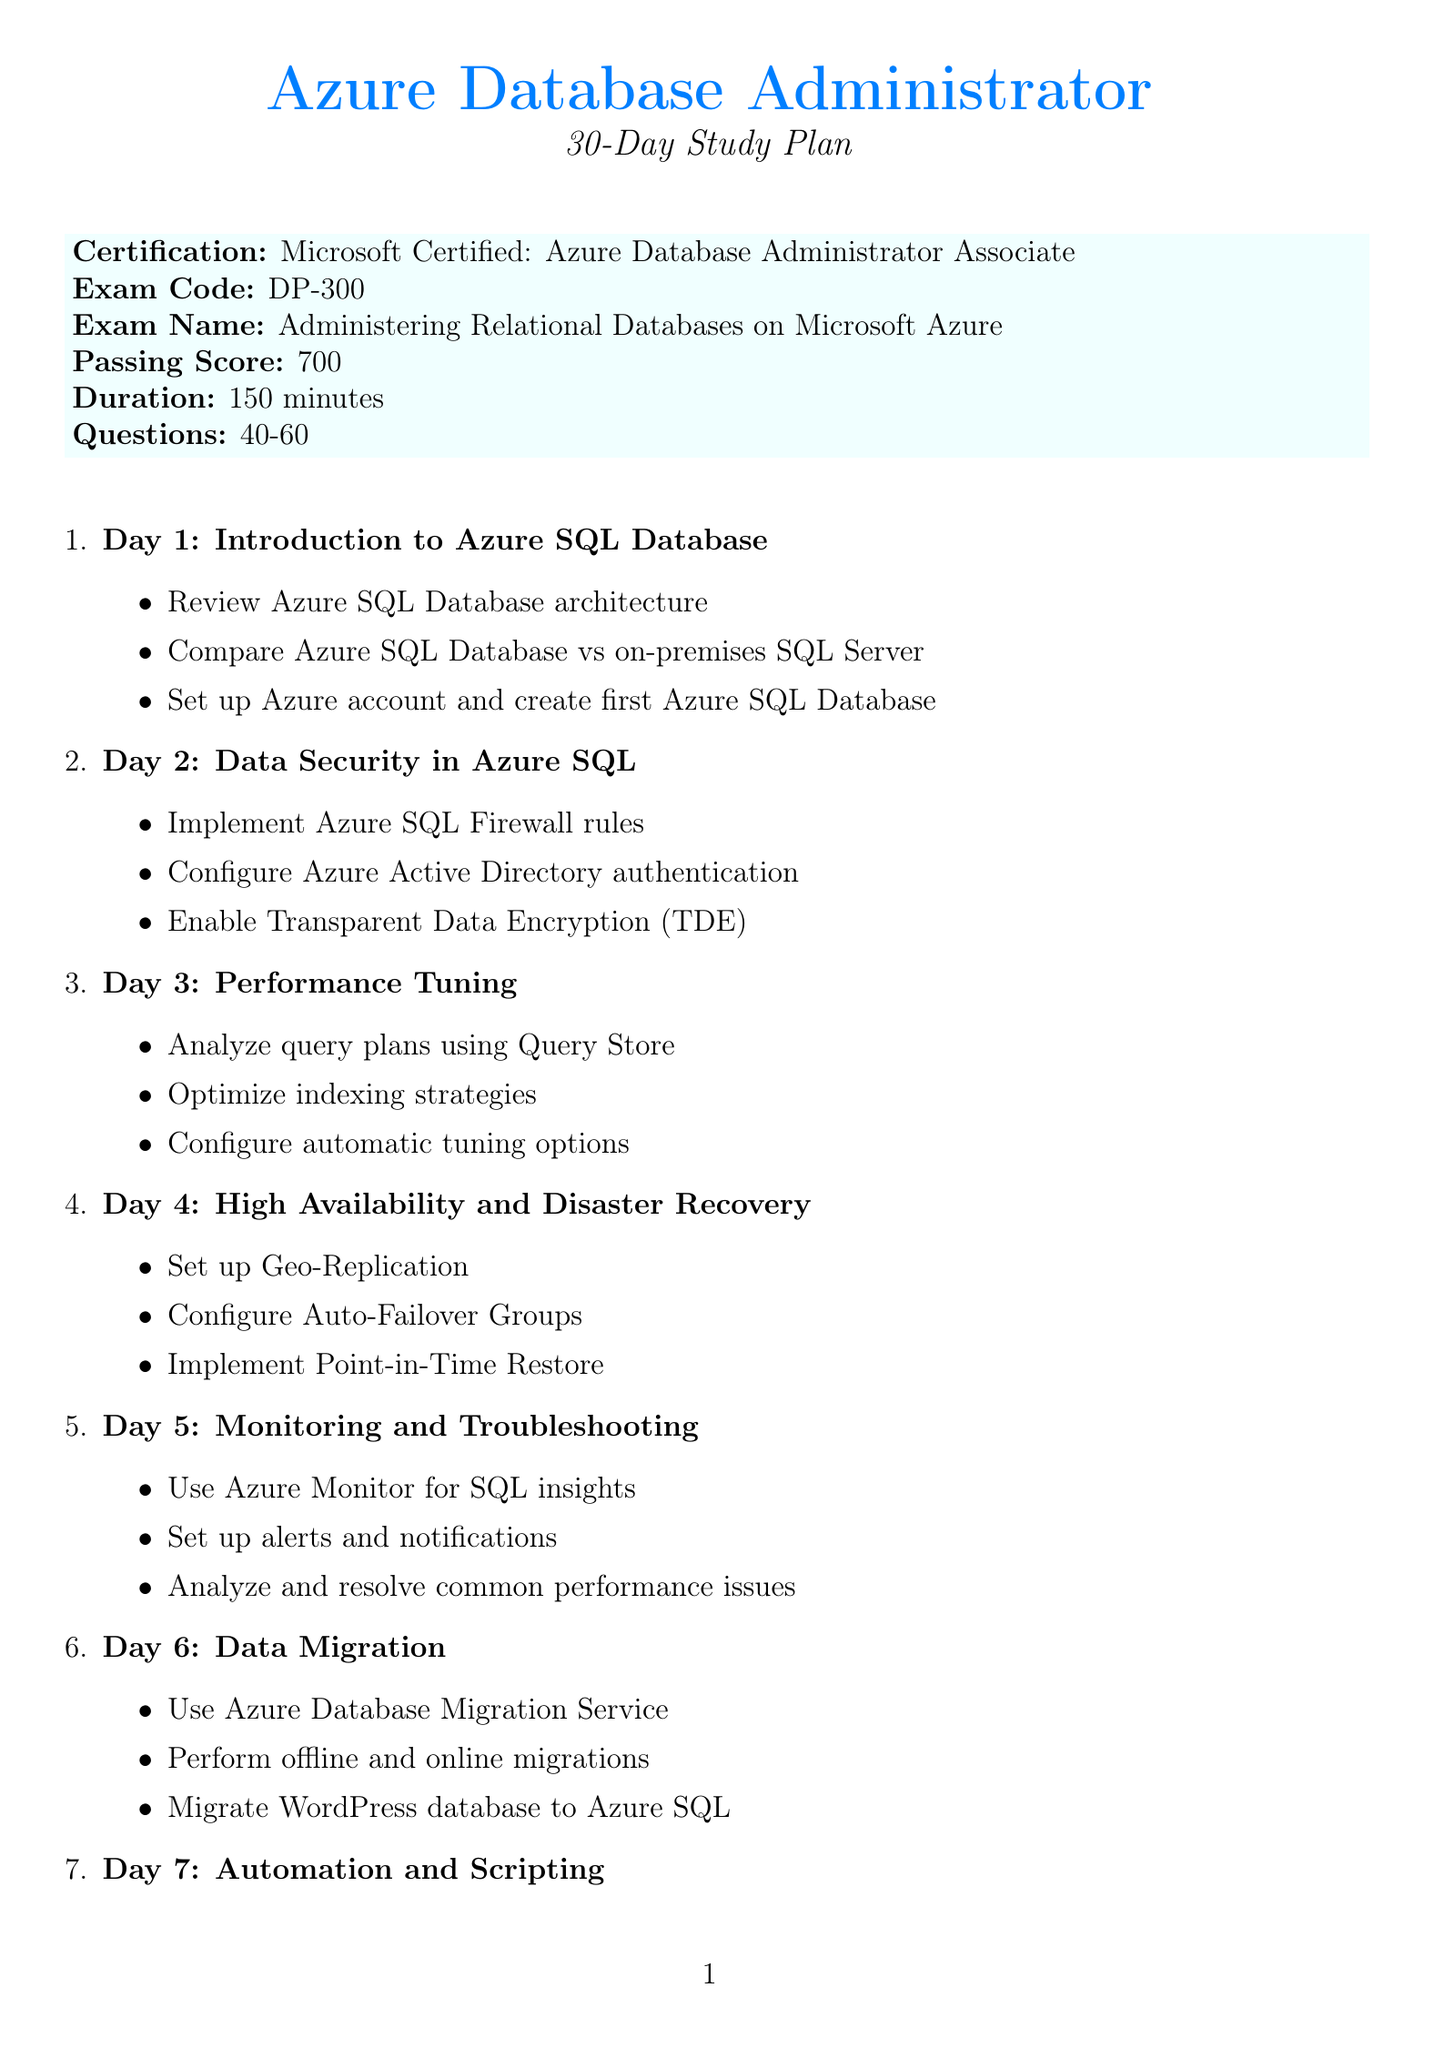what is the certification name? The certification name is stated at the beginning of the document.
Answer: Microsoft Certified: Azure Database Administrator Associate how many days is the study plan? The duration of the study plan is mentioned in the opening section of the document.
Answer: 30 days what is the passing score for the exam? The passing score for the exam is provided in the section detailing exam information.
Answer: 700 which day covers high availability and disaster recovery? The specific day for this topic can be found in the daily objectives section.
Answer: Day 4 what task is associated with day 6? Day 6 includes specific tasks listed under the corresponding topic.
Answer: Migrate WordPress database to Azure SQL how many topics are covered in the schedule? The total number of daily objectives gives insight into the total topics.
Answer: 30 what is the exam code? The exam code is specified under the exam details section.
Answer: DP-300 which resource is mentioned for optimizing database performance in WordPress? The resources section includes various materials for study, including this specific resource.
Answer: WordPress Codex: Optimizing Database Performance what day focuses on Azure SQL Database Hyperscale? This information can be found labeled in the daily objectives, indicating the focus for that day.
Answer: Day 22 